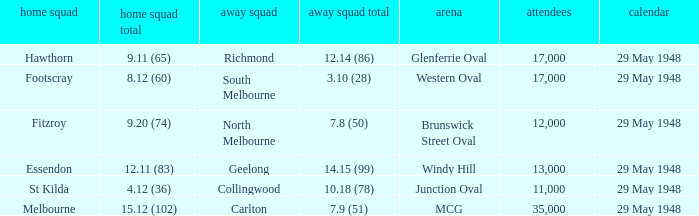In the match where footscray was the home team, how much did they score? 8.12 (60). 